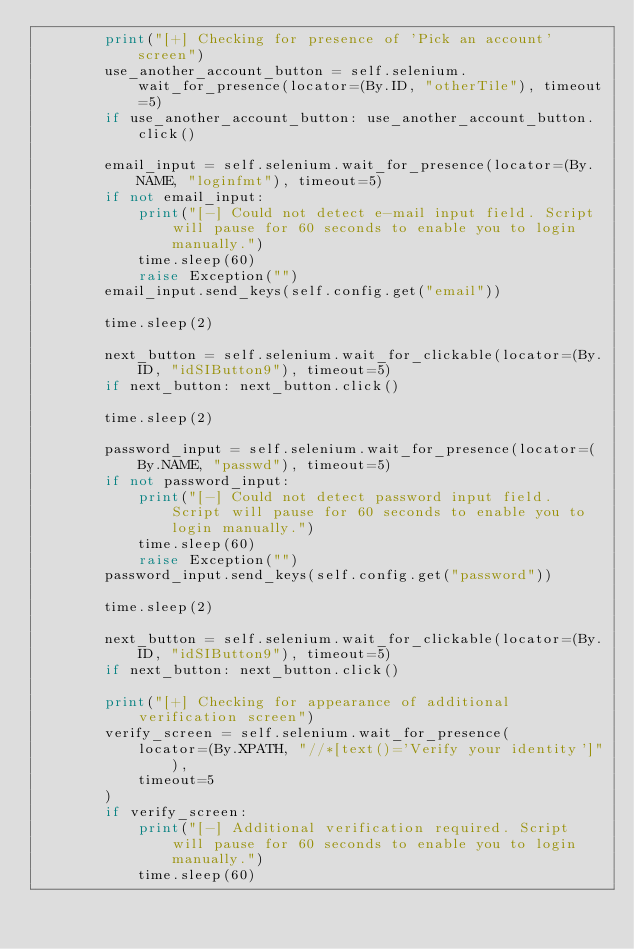Convert code to text. <code><loc_0><loc_0><loc_500><loc_500><_Python_>        print("[+] Checking for presence of 'Pick an account' screen")
        use_another_account_button = self.selenium.wait_for_presence(locator=(By.ID, "otherTile"), timeout=5)
        if use_another_account_button: use_another_account_button.click()

        email_input = self.selenium.wait_for_presence(locator=(By.NAME, "loginfmt"), timeout=5)
        if not email_input:
            print("[-] Could not detect e-mail input field. Script will pause for 60 seconds to enable you to login manually.")
            time.sleep(60)
            raise Exception("")
        email_input.send_keys(self.config.get("email"))

        time.sleep(2)

        next_button = self.selenium.wait_for_clickable(locator=(By.ID, "idSIButton9"), timeout=5)
        if next_button: next_button.click()

        time.sleep(2)

        password_input = self.selenium.wait_for_presence(locator=(By.NAME, "passwd"), timeout=5)
        if not password_input:
            print("[-] Could not detect password input field. Script will pause for 60 seconds to enable you to login manually.")
            time.sleep(60)
            raise Exception("")
        password_input.send_keys(self.config.get("password"))

        time.sleep(2)

        next_button = self.selenium.wait_for_clickable(locator=(By.ID, "idSIButton9"), timeout=5)
        if next_button: next_button.click()

        print("[+] Checking for appearance of additional verification screen")
        verify_screen = self.selenium.wait_for_presence(
            locator=(By.XPATH, "//*[text()='Verify your identity']"),
            timeout=5
        )
        if verify_screen:
            print("[-] Additional verification required. Script will pause for 60 seconds to enable you to login manually.")
            time.sleep(60)</code> 